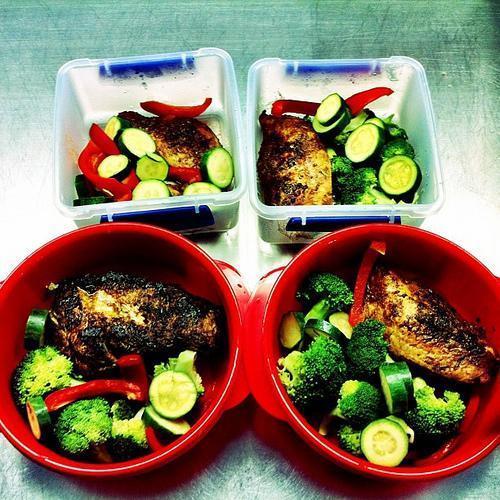How many food containers are red?
Give a very brief answer. 2. How many food containers are in this photo?
Give a very brief answer. 4. How many pieces of meat are in each container?
Give a very brief answer. 1. How many of the containers pictured are red?
Give a very brief answer. 2. 